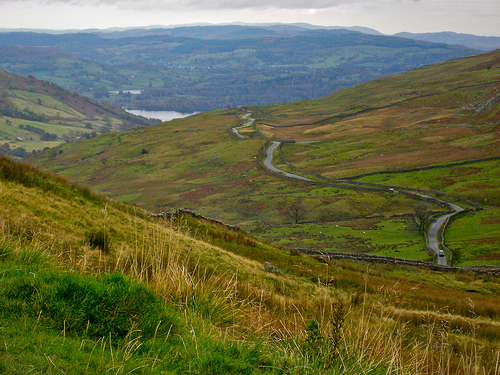<image>
Is there a pond in the hills? Yes. The pond is contained within or inside the hills, showing a containment relationship. 